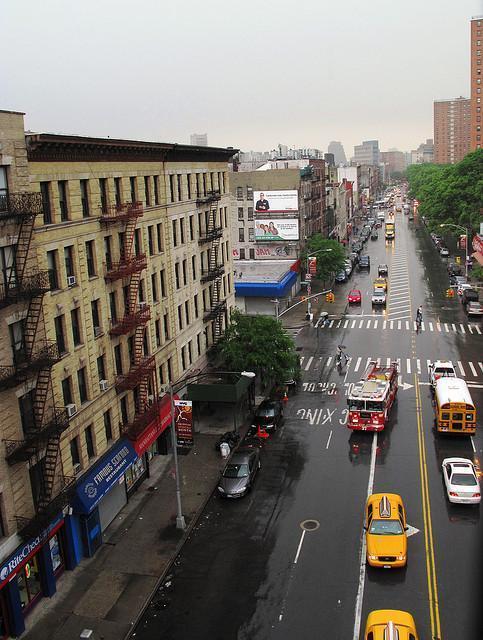How many fire escapes do you see?
Give a very brief answer. 3. How many cars are there?
Give a very brief answer. 2. 